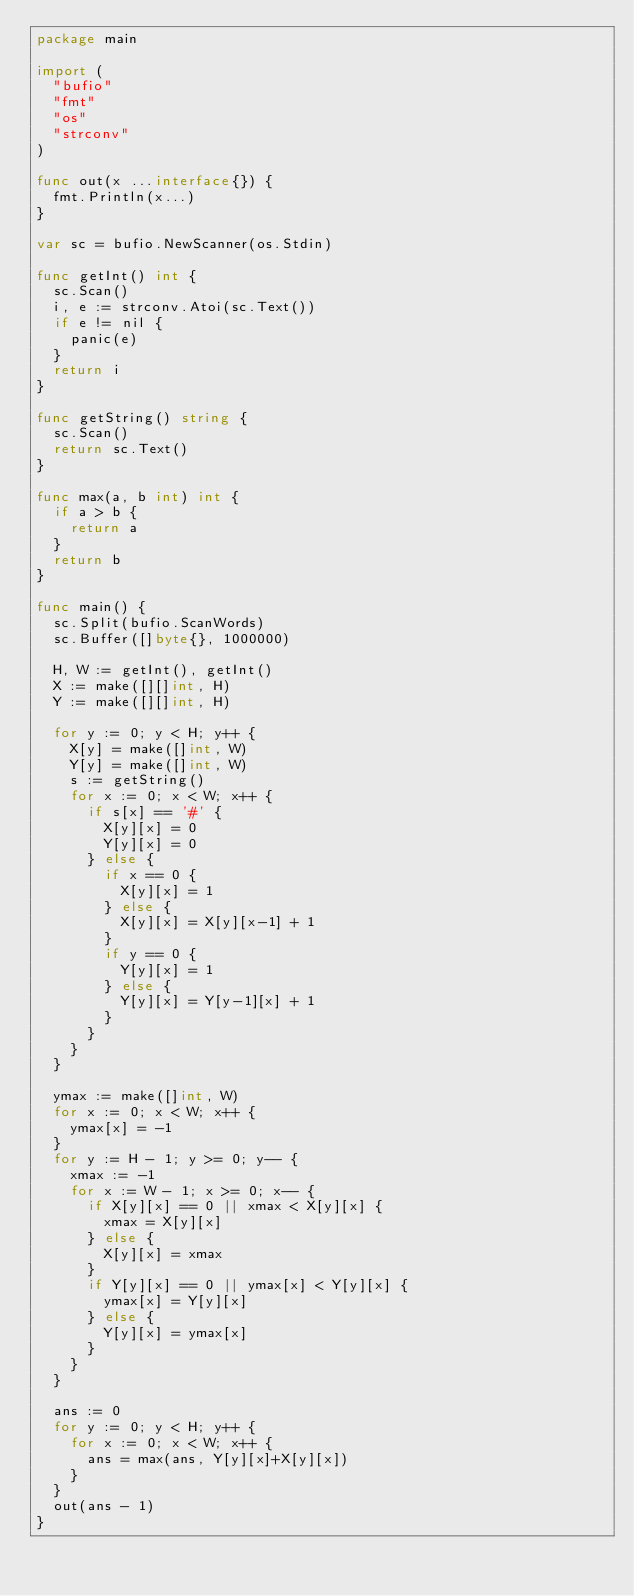<code> <loc_0><loc_0><loc_500><loc_500><_Go_>package main

import (
	"bufio"
	"fmt"
	"os"
	"strconv"
)

func out(x ...interface{}) {
	fmt.Println(x...)
}

var sc = bufio.NewScanner(os.Stdin)

func getInt() int {
	sc.Scan()
	i, e := strconv.Atoi(sc.Text())
	if e != nil {
		panic(e)
	}
	return i
}

func getString() string {
	sc.Scan()
	return sc.Text()
}

func max(a, b int) int {
	if a > b {
		return a
	}
	return b
}

func main() {
	sc.Split(bufio.ScanWords)
	sc.Buffer([]byte{}, 1000000)

	H, W := getInt(), getInt()
	X := make([][]int, H)
	Y := make([][]int, H)

	for y := 0; y < H; y++ {
		X[y] = make([]int, W)
		Y[y] = make([]int, W)
		s := getString()
		for x := 0; x < W; x++ {
			if s[x] == '#' {
				X[y][x] = 0
				Y[y][x] = 0
			} else {
				if x == 0 {
					X[y][x] = 1
				} else {
					X[y][x] = X[y][x-1] + 1
				}
				if y == 0 {
					Y[y][x] = 1
				} else {
					Y[y][x] = Y[y-1][x] + 1
				}
			}
		}
	}

	ymax := make([]int, W)
	for x := 0; x < W; x++ {
		ymax[x] = -1
	}
	for y := H - 1; y >= 0; y-- {
		xmax := -1
		for x := W - 1; x >= 0; x-- {
			if X[y][x] == 0 || xmax < X[y][x] {
				xmax = X[y][x]
			} else {
				X[y][x] = xmax
			}
			if Y[y][x] == 0 || ymax[x] < Y[y][x] {
				ymax[x] = Y[y][x]
			} else {
				Y[y][x] = ymax[x]
			}
		}
	}

	ans := 0
	for y := 0; y < H; y++ {
		for x := 0; x < W; x++ {
			ans = max(ans, Y[y][x]+X[y][x])
		}
	}
	out(ans - 1)
}
</code> 